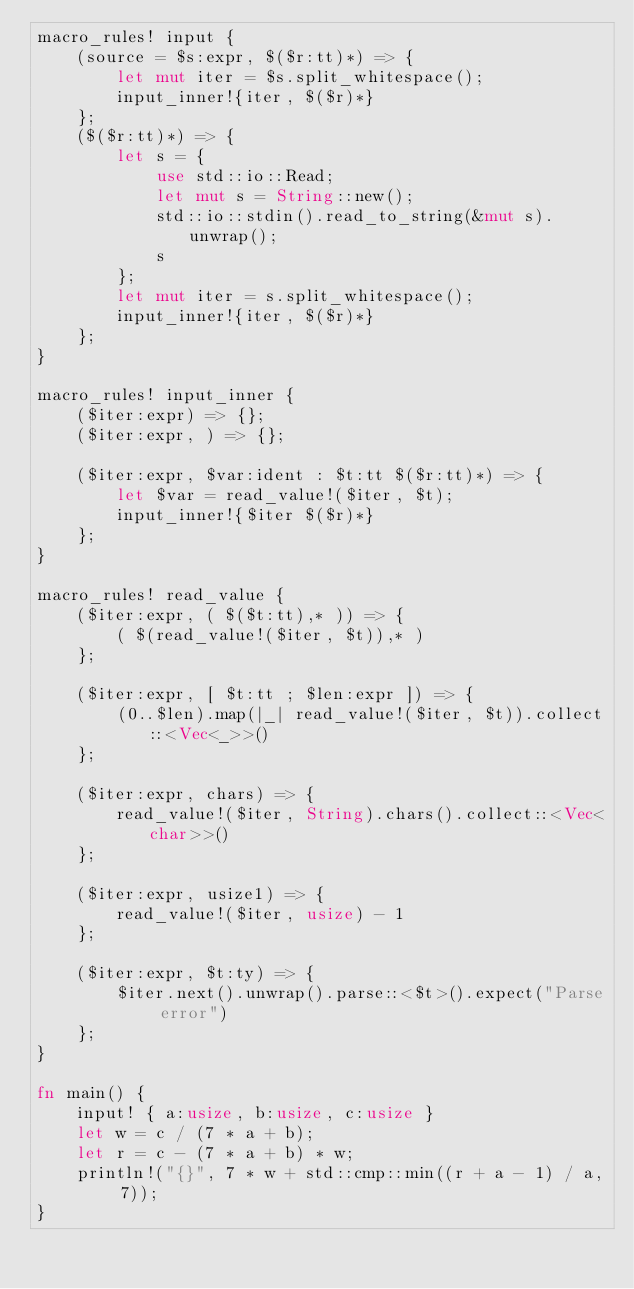<code> <loc_0><loc_0><loc_500><loc_500><_Rust_>macro_rules! input {
    (source = $s:expr, $($r:tt)*) => {
        let mut iter = $s.split_whitespace();
        input_inner!{iter, $($r)*}
    };
    ($($r:tt)*) => {
        let s = {
            use std::io::Read;
            let mut s = String::new();
            std::io::stdin().read_to_string(&mut s).unwrap();
            s
        };
        let mut iter = s.split_whitespace();
        input_inner!{iter, $($r)*}
    };
}

macro_rules! input_inner {
    ($iter:expr) => {};
    ($iter:expr, ) => {};

    ($iter:expr, $var:ident : $t:tt $($r:tt)*) => {
        let $var = read_value!($iter, $t);
        input_inner!{$iter $($r)*}
    };
}

macro_rules! read_value {
    ($iter:expr, ( $($t:tt),* )) => {
        ( $(read_value!($iter, $t)),* )
    };

    ($iter:expr, [ $t:tt ; $len:expr ]) => {
        (0..$len).map(|_| read_value!($iter, $t)).collect::<Vec<_>>()
    };

    ($iter:expr, chars) => {
        read_value!($iter, String).chars().collect::<Vec<char>>()
    };

    ($iter:expr, usize1) => {
        read_value!($iter, usize) - 1
    };

    ($iter:expr, $t:ty) => {
        $iter.next().unwrap().parse::<$t>().expect("Parse error")
    };
}

fn main() {
    input! { a:usize, b:usize, c:usize }
    let w = c / (7 * a + b);
    let r = c - (7 * a + b) * w;
    println!("{}", 7 * w + std::cmp::min((r + a - 1) / a, 7));
}

</code> 